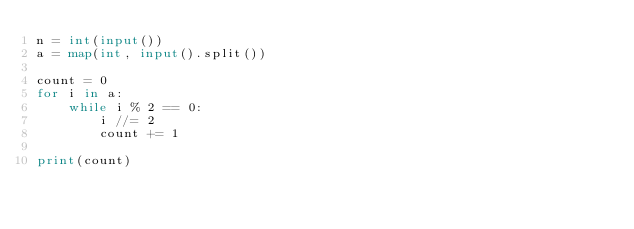Convert code to text. <code><loc_0><loc_0><loc_500><loc_500><_Python_>n = int(input())
a = map(int, input().split())

count = 0
for i in a:
    while i % 2 == 0:
        i //= 2
        count += 1
            
print(count)</code> 